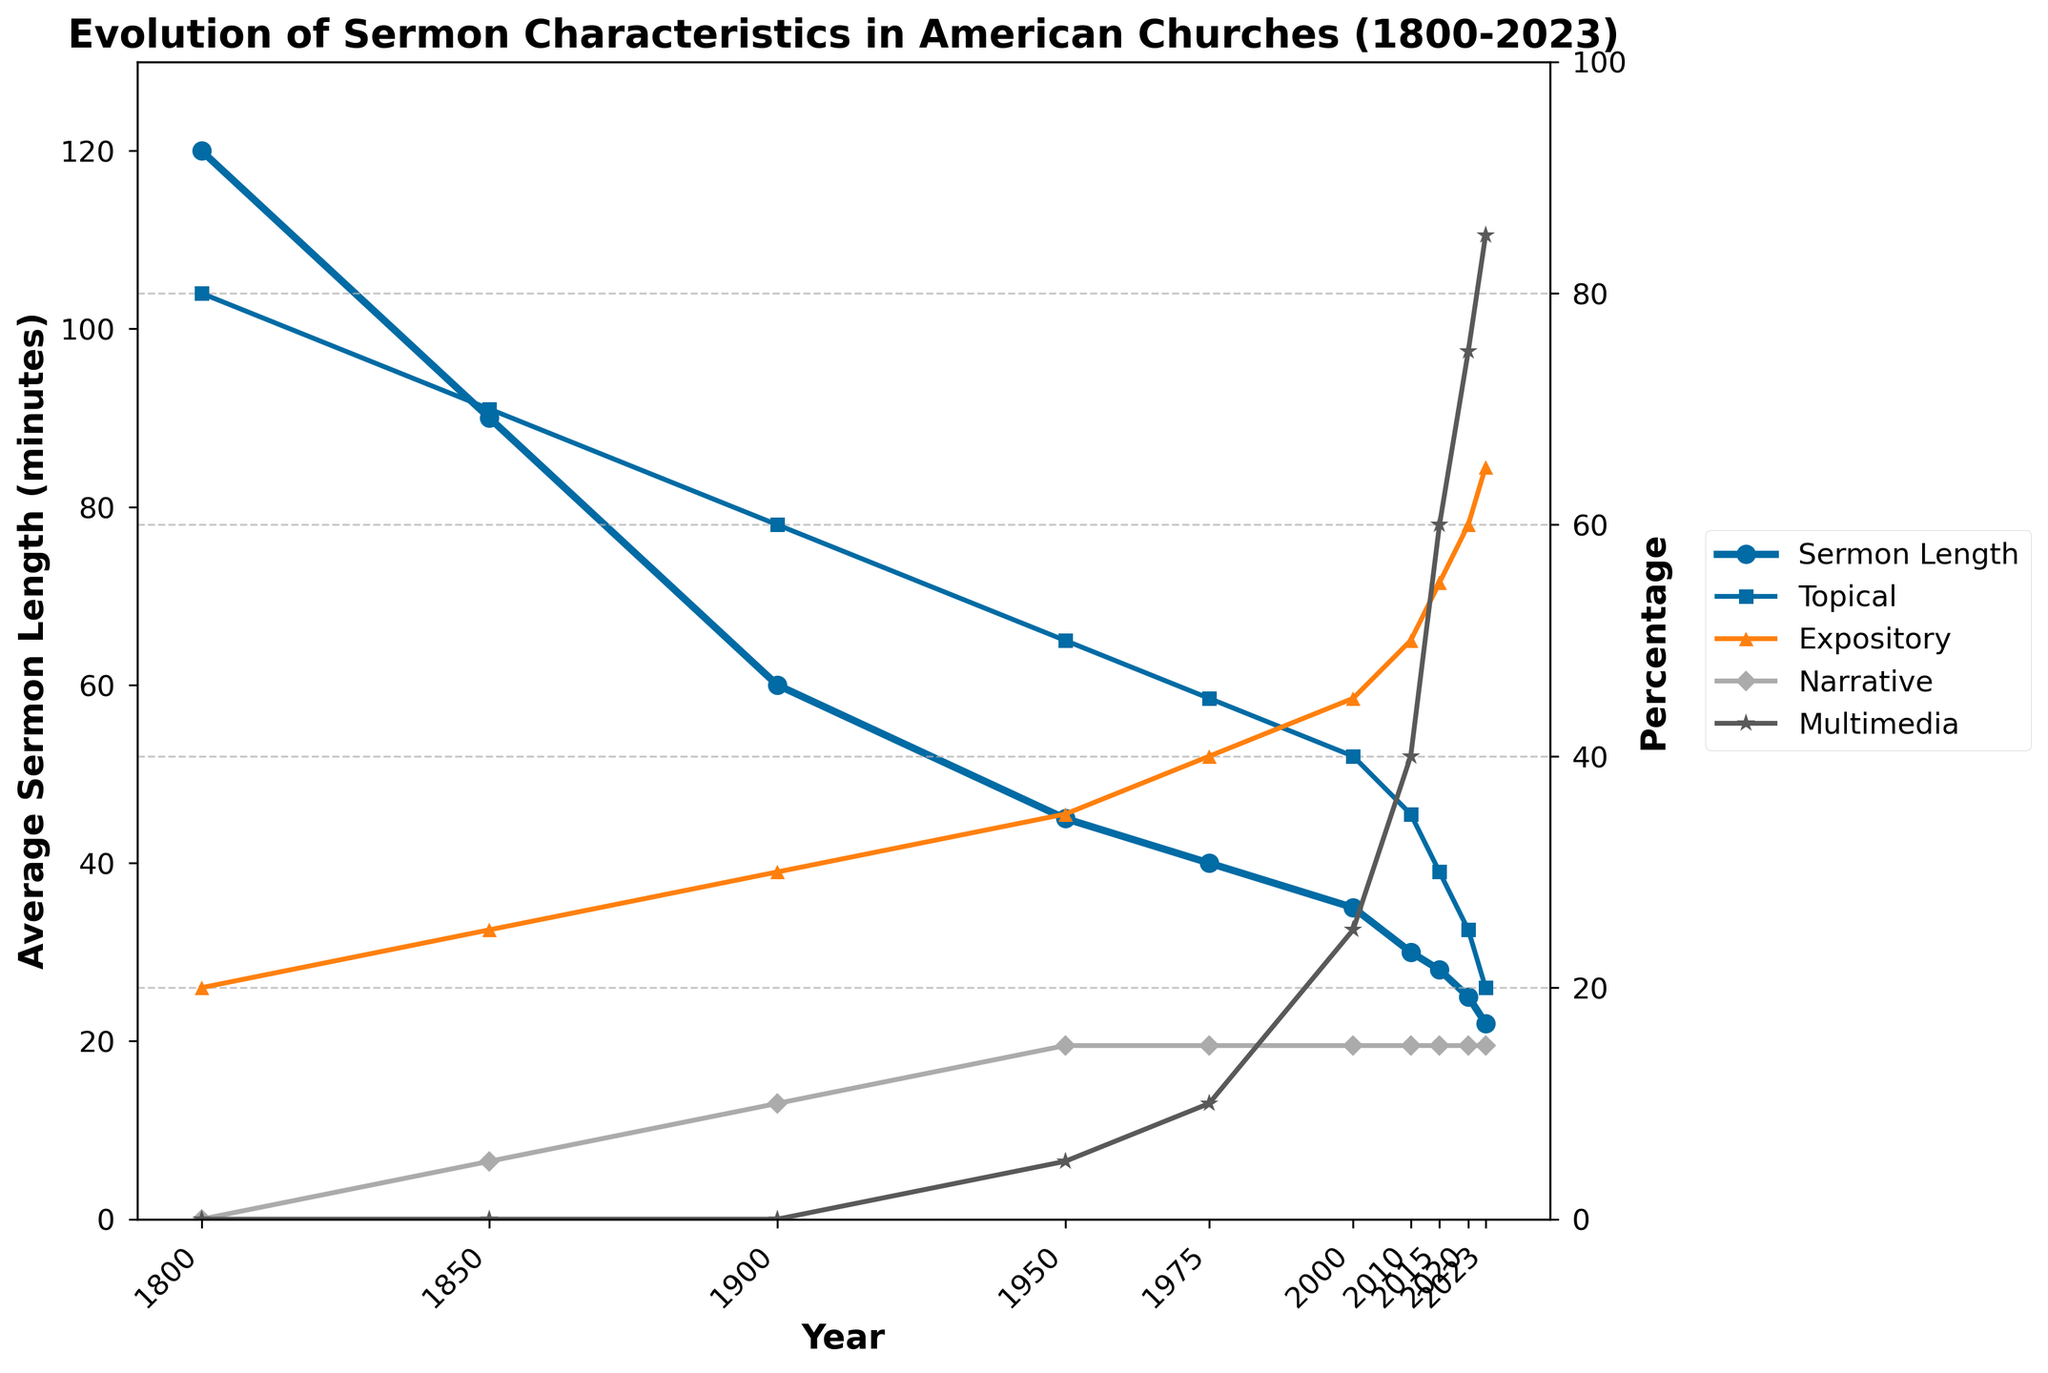What's the average sermon length in the year 1850 and the year 2020? The figure shows that in 1850, the average sermon length is 90 minutes. In 2020, it is 25 minutes. The average of these two values is (90 + 25) / 2 = 57.5 minutes
Answer: 57.5 minutes By how much has the average sermon length decreased from 1800 to 2023? The average sermon length in 1800 is 120 minutes and in 2023 it is 22 minutes. The decrease is 120 - 22 = 98 minutes
Answer: 98 minutes What is the percentage increase in the use of multimedia from 1975 to 2023? In 1975, the use of multimedia is 10%, and in 2023, it is 85%. The increase in percentage is (85 - 10) / 10 * 100 = 750%
Answer: 750% Which year marks the highest percentage of expository sermons, and what is the percentage? The figure shows the line for expository sermons (%), which peaks in 2023 at 65%
Answer: 2023, 65% Is there a year where the percentage of topical sermons is equal to the percentage of narrative sermons? The percentages for topical and narrative sermons are plotted for each year. From the visual aid, they do not equal each other in any year from 1800 to 2023
Answer: No What is the trend in the percentage of topical sermons from 1800 to 2023? The line for topical sermons (%) shows a decreasing trend from 80% in 1800 to 20% in 2023
Answer: Decreasing How does the average sermon length in 1900 compare to the average sermon length in 2000? In 1900, the average sermon length is 60 minutes, while in 2000, it is 35 minutes. Therefore, the sermon length in 1900 is longer by 25 minutes
Answer: 25 minutes longer Which type of sermon had an equal percentage in 1950, 1975, and 2000, and what is that percentage? The percentage of narrative sermons is consistently 15% in 1950, 1975, and 2000 as displayed in the data trends
Answer: Narrative sermons, 15% In which period did the most significant decrease in average sermon length occur? Observing the line for average sermon length, the most significant drop occurs between 1800 and 1850, decreasing from 120 minutes to 90 minutes
Answer: 1800 to 1850 How does the use of multimedia in 2010 compare visually with the use of multimedia in 2023? In 2010, the figure shows a significantly lower value, around 40%, while in 2023, the use of multimedia reaches a much higher value at 85%
Answer: Much higher in 2023 